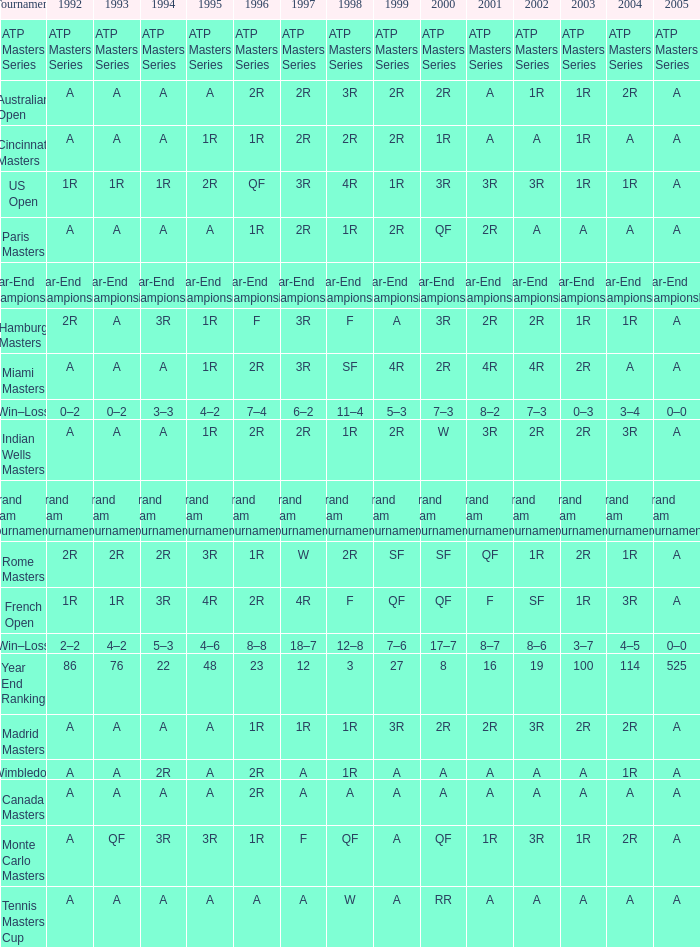What is Tournament, when 2000 is "A"? Wimbledon, Canada Masters. 